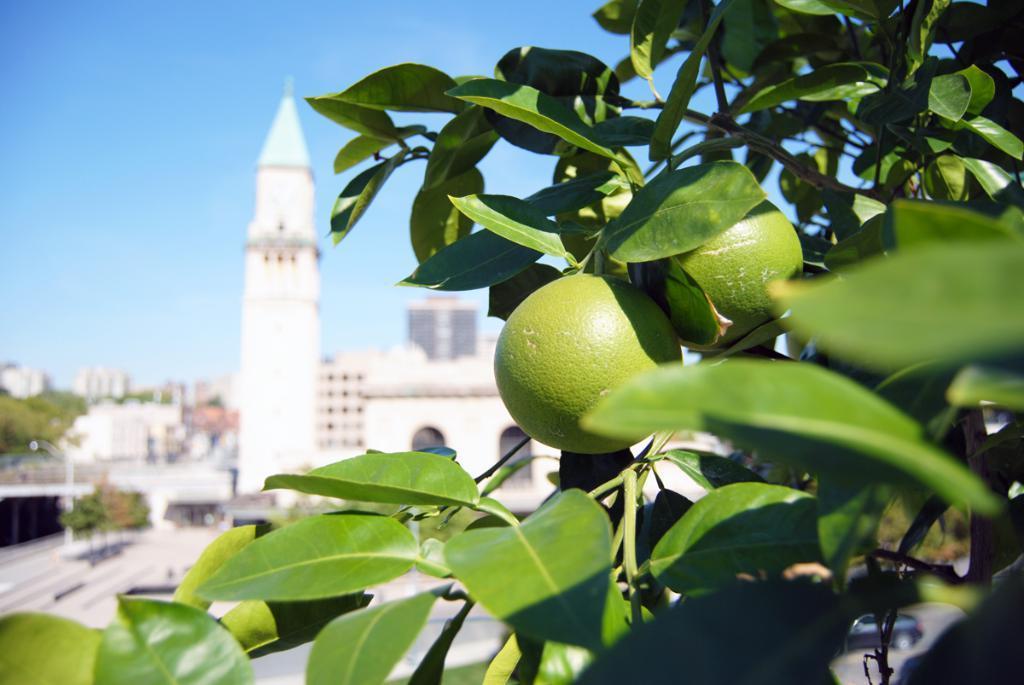Please provide a concise description of this image. In this image on the right, there are plants, leaves, fruits. In the background there are buildings, trees, steeple, sky. 